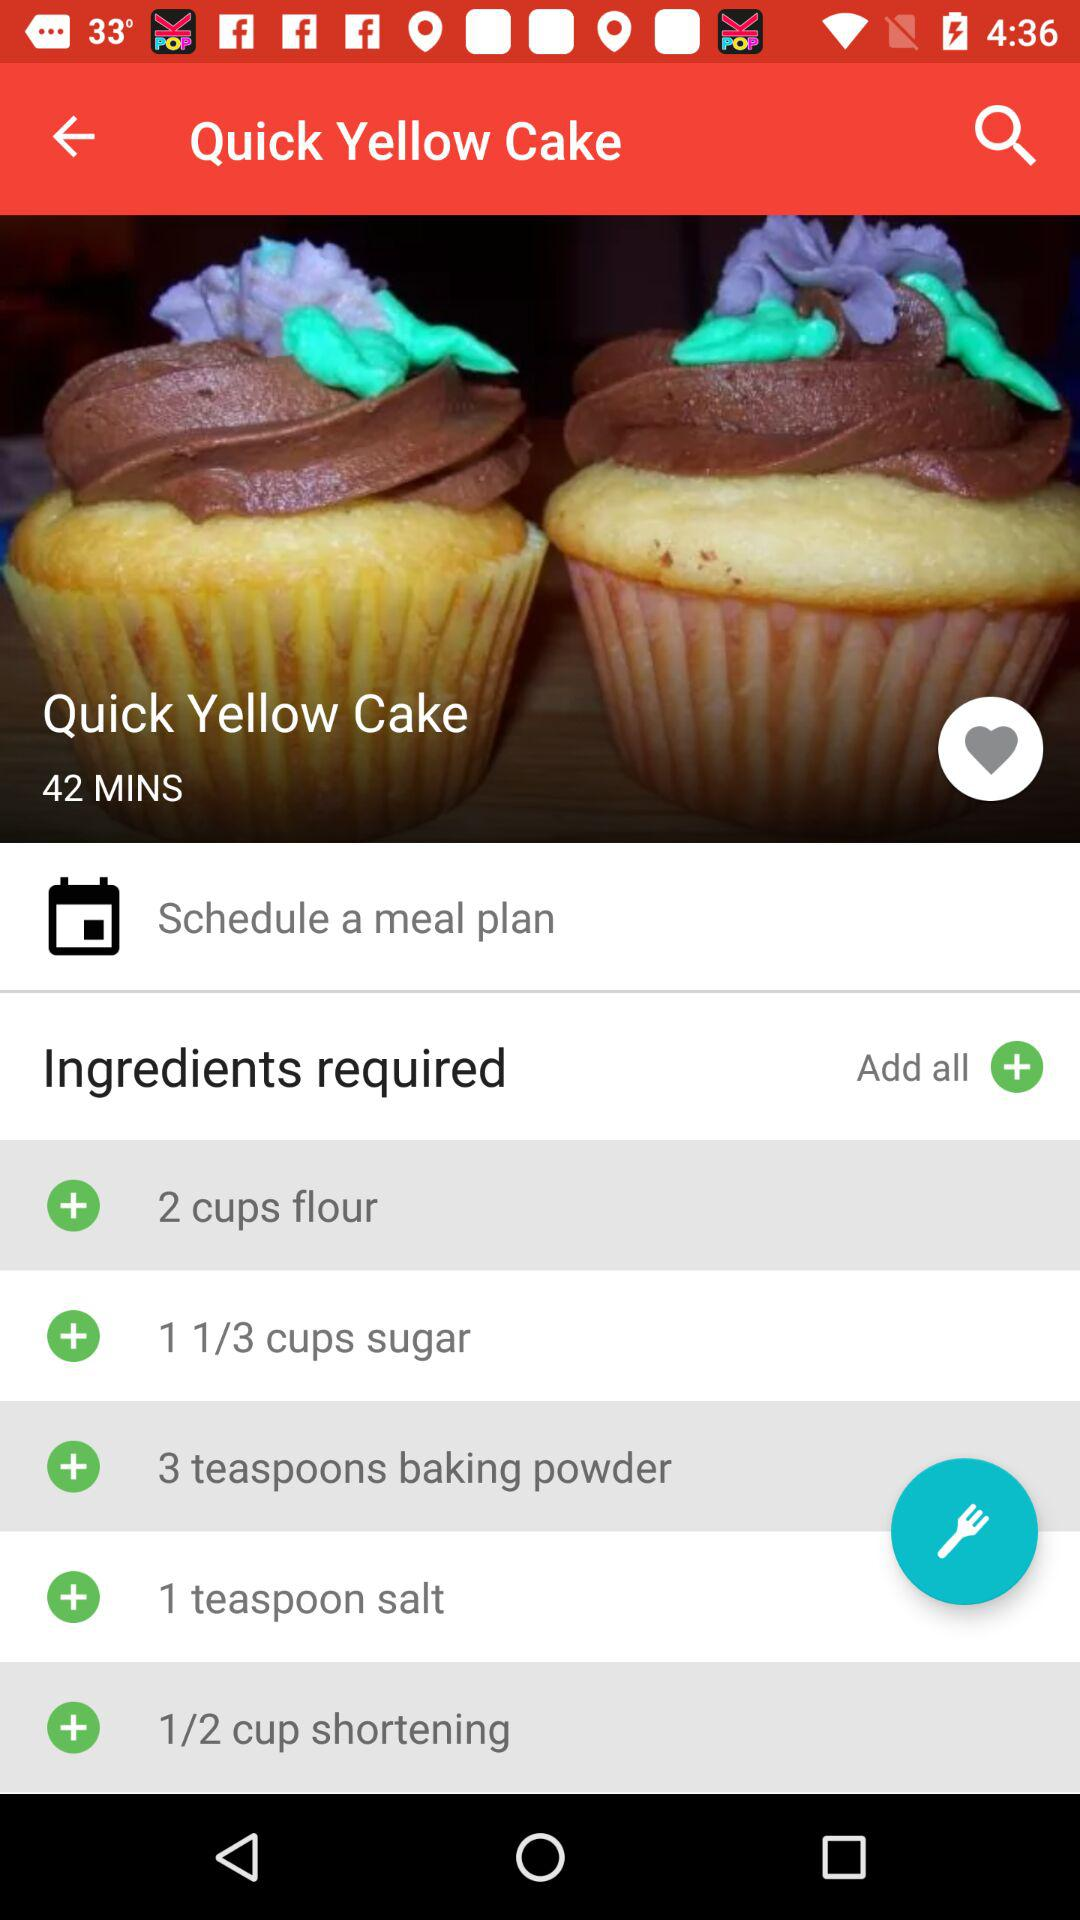What are the required ingredients? The required ingredients are 2 cups flour, 1 1/3 cups sugar, 3 teaspoons baking powder, 1 teaspoon salt and 1/2 cup shortening. 